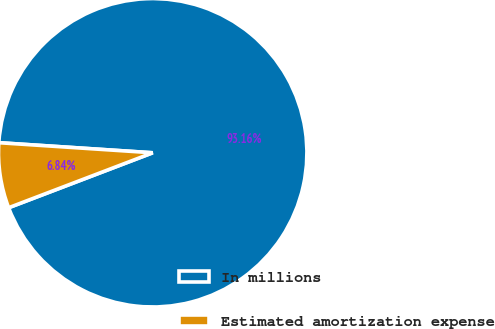Convert chart to OTSL. <chart><loc_0><loc_0><loc_500><loc_500><pie_chart><fcel>In millions<fcel>Estimated amortization expense<nl><fcel>93.16%<fcel>6.84%<nl></chart> 